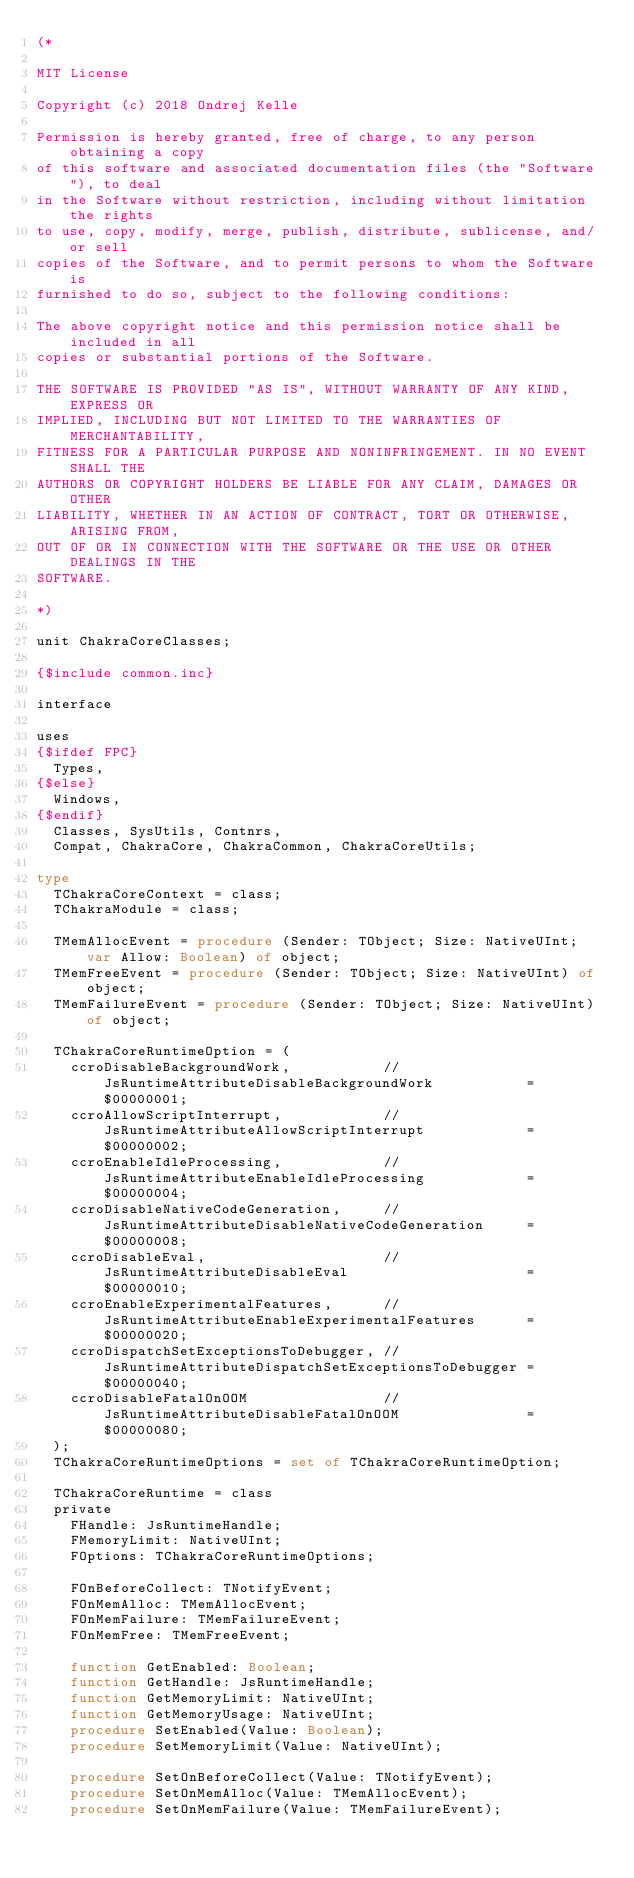Convert code to text. <code><loc_0><loc_0><loc_500><loc_500><_Pascal_>(*

MIT License

Copyright (c) 2018 Ondrej Kelle

Permission is hereby granted, free of charge, to any person obtaining a copy
of this software and associated documentation files (the "Software"), to deal
in the Software without restriction, including without limitation the rights
to use, copy, modify, merge, publish, distribute, sublicense, and/or sell
copies of the Software, and to permit persons to whom the Software is
furnished to do so, subject to the following conditions:

The above copyright notice and this permission notice shall be included in all
copies or substantial portions of the Software.

THE SOFTWARE IS PROVIDED "AS IS", WITHOUT WARRANTY OF ANY KIND, EXPRESS OR
IMPLIED, INCLUDING BUT NOT LIMITED TO THE WARRANTIES OF MERCHANTABILITY,
FITNESS FOR A PARTICULAR PURPOSE AND NONINFRINGEMENT. IN NO EVENT SHALL THE
AUTHORS OR COPYRIGHT HOLDERS BE LIABLE FOR ANY CLAIM, DAMAGES OR OTHER
LIABILITY, WHETHER IN AN ACTION OF CONTRACT, TORT OR OTHERWISE, ARISING FROM,
OUT OF OR IN CONNECTION WITH THE SOFTWARE OR THE USE OR OTHER DEALINGS IN THE
SOFTWARE.

*)

unit ChakraCoreClasses;

{$include common.inc}

interface

uses
{$ifdef FPC}
  Types,
{$else}
  Windows,
{$endif}
  Classes, SysUtils, Contnrs,
  Compat, ChakraCore, ChakraCommon, ChakraCoreUtils;

type
  TChakraCoreContext = class;
  TChakraModule = class;

  TMemAllocEvent = procedure (Sender: TObject; Size: NativeUInt; var Allow: Boolean) of object;
  TMemFreeEvent = procedure (Sender: TObject; Size: NativeUInt) of object;
  TMemFailureEvent = procedure (Sender: TObject; Size: NativeUInt) of object;

  TChakraCoreRuntimeOption = (
    ccroDisableBackgroundWork,           // JsRuntimeAttributeDisableBackgroundWork           = $00000001;
    ccroAllowScriptInterrupt,            // JsRuntimeAttributeAllowScriptInterrupt            = $00000002;
    ccroEnableIdleProcessing,            // JsRuntimeAttributeEnableIdleProcessing            = $00000004;
    ccroDisableNativeCodeGeneration,     // JsRuntimeAttributeDisableNativeCodeGeneration     = $00000008;
    ccroDisableEval,                     // JsRuntimeAttributeDisableEval                     = $00000010;
    ccroEnableExperimentalFeatures,      // JsRuntimeAttributeEnableExperimentalFeatures      = $00000020;
    ccroDispatchSetExceptionsToDebugger, // JsRuntimeAttributeDispatchSetExceptionsToDebugger = $00000040;
    ccroDisableFatalOnOOM                // JsRuntimeAttributeDisableFatalOnOOM               = $00000080;
  );
  TChakraCoreRuntimeOptions = set of TChakraCoreRuntimeOption;

  TChakraCoreRuntime = class
  private
    FHandle: JsRuntimeHandle;
    FMemoryLimit: NativeUInt;
    FOptions: TChakraCoreRuntimeOptions;

    FOnBeforeCollect: TNotifyEvent;
    FOnMemAlloc: TMemAllocEvent;
    FOnMemFailure: TMemFailureEvent;
    FOnMemFree: TMemFreeEvent;

    function GetEnabled: Boolean;
    function GetHandle: JsRuntimeHandle;
    function GetMemoryLimit: NativeUInt;
    function GetMemoryUsage: NativeUInt;
    procedure SetEnabled(Value: Boolean);
    procedure SetMemoryLimit(Value: NativeUInt);

    procedure SetOnBeforeCollect(Value: TNotifyEvent);
    procedure SetOnMemAlloc(Value: TMemAllocEvent);
    procedure SetOnMemFailure(Value: TMemFailureEvent);</code> 